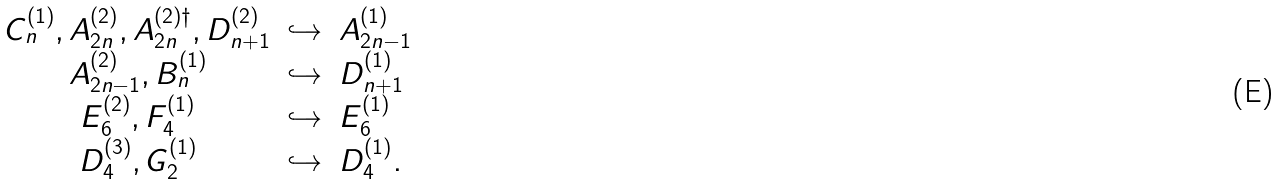<formula> <loc_0><loc_0><loc_500><loc_500>\begin{array} { c l l } C _ { n } ^ { ( 1 ) } , A _ { 2 n } ^ { ( 2 ) } , A _ { 2 n } ^ { ( 2 ) \dagger } , D _ { n + 1 } ^ { ( 2 ) } & \hookrightarrow & A _ { 2 n - 1 } ^ { ( 1 ) } \\ A _ { 2 n - 1 } ^ { ( 2 ) } , B _ { n } ^ { ( 1 ) } & \hookrightarrow & D _ { n + 1 } ^ { ( 1 ) } \\ E _ { 6 } ^ { ( 2 ) } , F _ { 4 } ^ { ( 1 ) } & \hookrightarrow & E _ { 6 } ^ { ( 1 ) } \\ D _ { 4 } ^ { ( 3 ) } , G _ { 2 } ^ { ( 1 ) } & \hookrightarrow & D _ { 4 } ^ { ( 1 ) } . \end{array}</formula> 